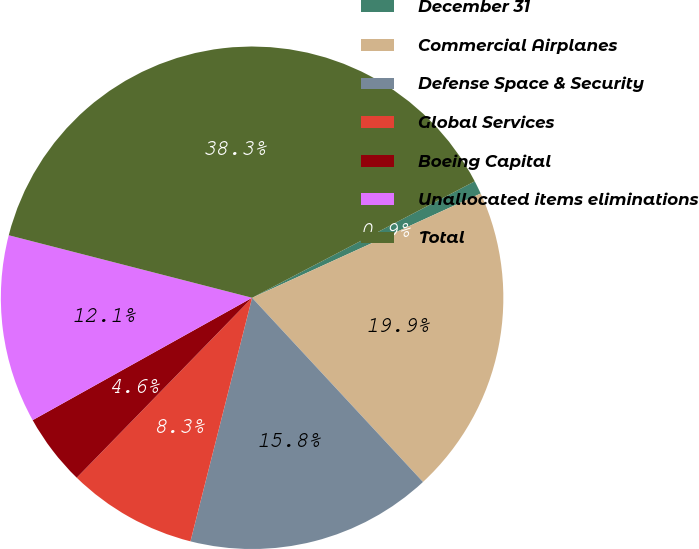<chart> <loc_0><loc_0><loc_500><loc_500><pie_chart><fcel>December 31<fcel>Commercial Airplanes<fcel>Defense Space & Security<fcel>Global Services<fcel>Boeing Capital<fcel>Unallocated items eliminations<fcel>Total<nl><fcel>0.86%<fcel>19.91%<fcel>15.85%<fcel>8.35%<fcel>4.61%<fcel>12.1%<fcel>38.33%<nl></chart> 